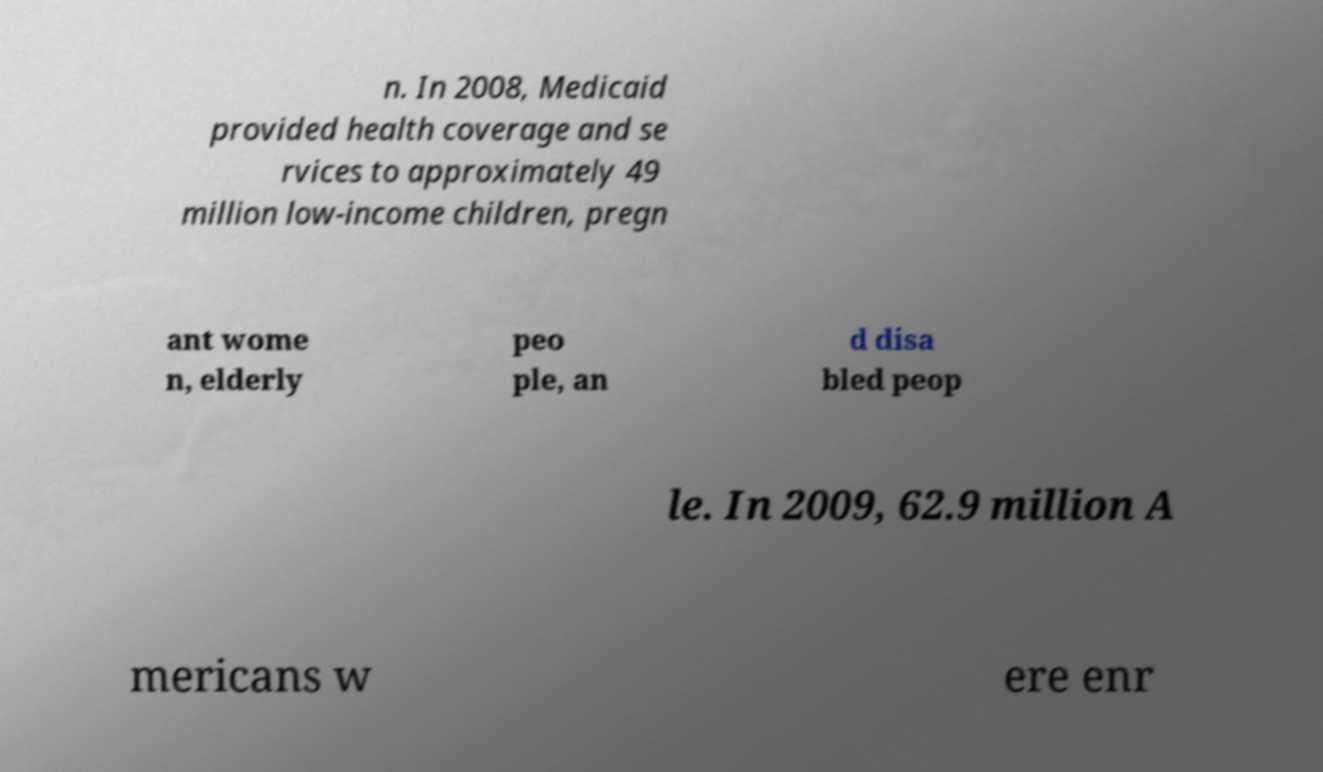There's text embedded in this image that I need extracted. Can you transcribe it verbatim? n. In 2008, Medicaid provided health coverage and se rvices to approximately 49 million low-income children, pregn ant wome n, elderly peo ple, an d disa bled peop le. In 2009, 62.9 million A mericans w ere enr 